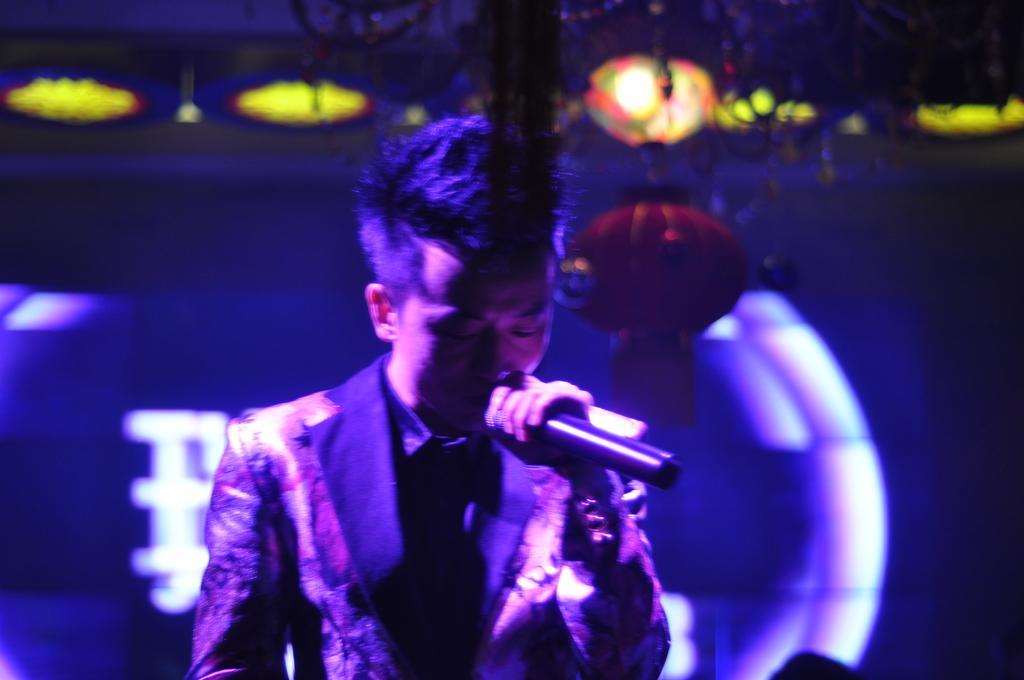What is the person in the image doing? The person is singing. What object is the person holding while singing? The person is holding a microphone. What can be seen at the top of the image? There are lights visible at the top of the image. Can you describe the background of the image? There is a design in the background of the image. What type of oil is being used to lubricate the chicken's boot in the image? There is no chicken or boot present in the image, and therefore no oil is being used for lubrication. 